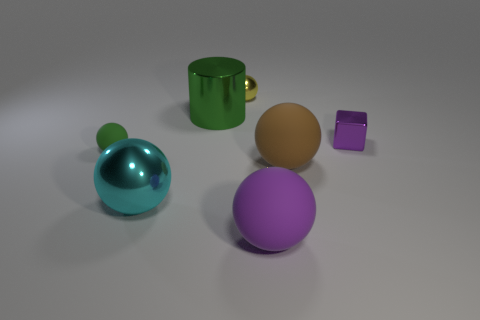There is a cyan ball that is the same size as the purple rubber ball; what is it made of?
Offer a terse response. Metal. How many things are big spheres to the left of the yellow thing or big gray cylinders?
Offer a terse response. 1. Are there an equal number of metal spheres behind the cyan metallic ball and brown rubber things?
Your answer should be very brief. Yes. Is the metal cylinder the same color as the small metal cube?
Provide a short and direct response. No. The matte thing that is both right of the cyan metallic object and behind the cyan metal sphere is what color?
Your answer should be very brief. Brown. How many blocks are cyan things or small things?
Give a very brief answer. 1. Are there fewer purple balls that are left of the green metallic object than big shiny balls?
Offer a very short reply. Yes. There is a small purple object that is the same material as the large cylinder; what is its shape?
Your response must be concise. Cube. What number of other metallic cubes have the same color as the shiny block?
Ensure brevity in your answer.  0. What number of things are either purple matte things or large cyan things?
Your answer should be compact. 2. 